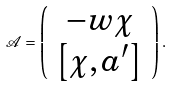Convert formula to latex. <formula><loc_0><loc_0><loc_500><loc_500>\mathcal { A } = \left ( \begin{array} { c } - w \chi \\ \left [ \chi , a ^ { \prime } \right ] \end{array} \right ) .</formula> 